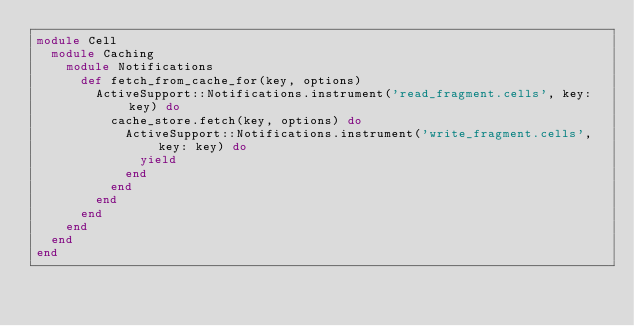Convert code to text. <code><loc_0><loc_0><loc_500><loc_500><_Ruby_>module Cell
  module Caching
    module Notifications
      def fetch_from_cache_for(key, options)
        ActiveSupport::Notifications.instrument('read_fragment.cells', key: key) do
          cache_store.fetch(key, options) do
            ActiveSupport::Notifications.instrument('write_fragment.cells', key: key) do
              yield
            end
          end
        end
      end
    end
  end
end
</code> 